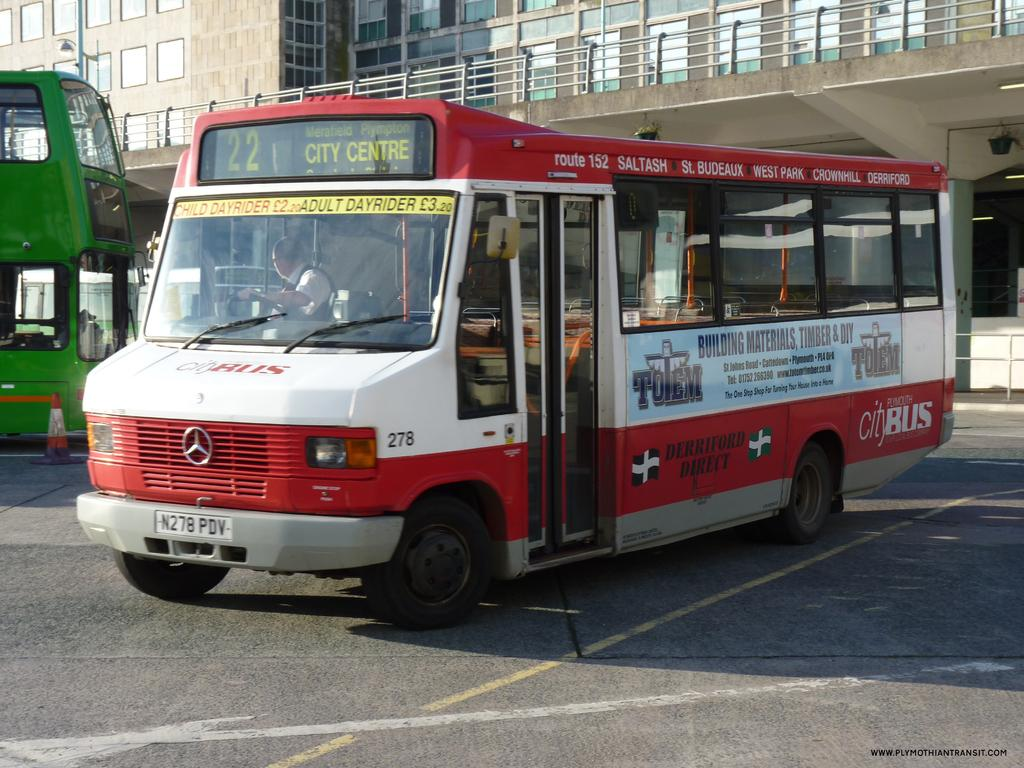What type of structure is visible in the image? There is a building in the image. What mode of transportation can be seen in the image? There are at least two buses in the image. Where is the playground located in the image? There is no playground present in the image. What type of bread is being used to fuel the volcano in the image? There is no bread or volcano present in the image. 